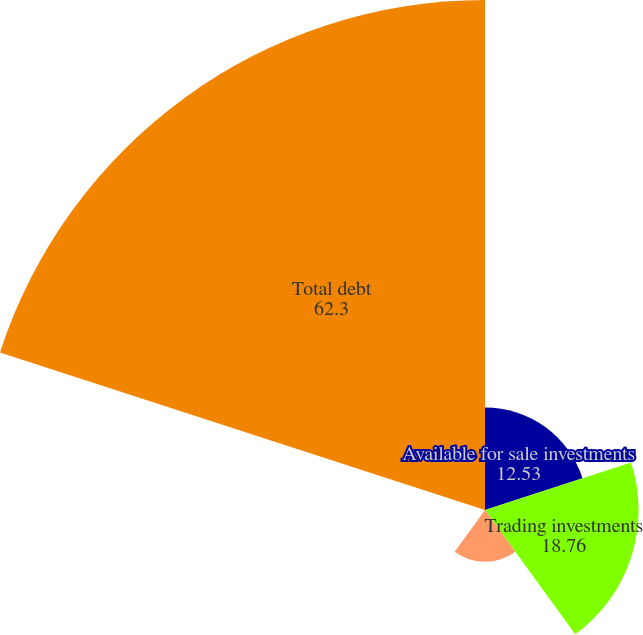<chart> <loc_0><loc_0><loc_500><loc_500><pie_chart><fcel>Available for sale investments<fcel>Trading investments<fcel>Foreign time deposits<fcel>Support agreements<fcel>Total debt<nl><fcel>12.53%<fcel>18.76%<fcel>6.31%<fcel>0.09%<fcel>62.3%<nl></chart> 